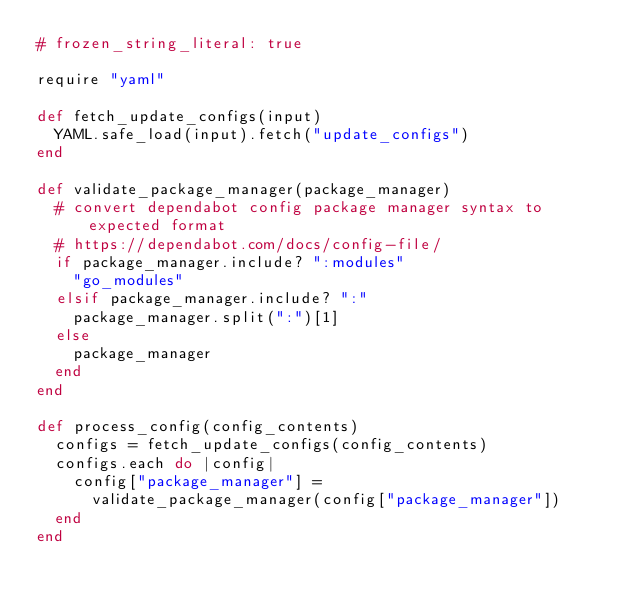<code> <loc_0><loc_0><loc_500><loc_500><_Ruby_># frozen_string_literal: true

require "yaml"

def fetch_update_configs(input)
  YAML.safe_load(input).fetch("update_configs")
end

def validate_package_manager(package_manager)
  # convert dependabot config package manager syntax to expected format
  # https://dependabot.com/docs/config-file/
  if package_manager.include? ":modules"
    "go_modules"
  elsif package_manager.include? ":"
    package_manager.split(":")[1]
  else
    package_manager
  end
end

def process_config(config_contents)
  configs = fetch_update_configs(config_contents)
  configs.each do |config|
    config["package_manager"] =
      validate_package_manager(config["package_manager"])
  end
end
</code> 